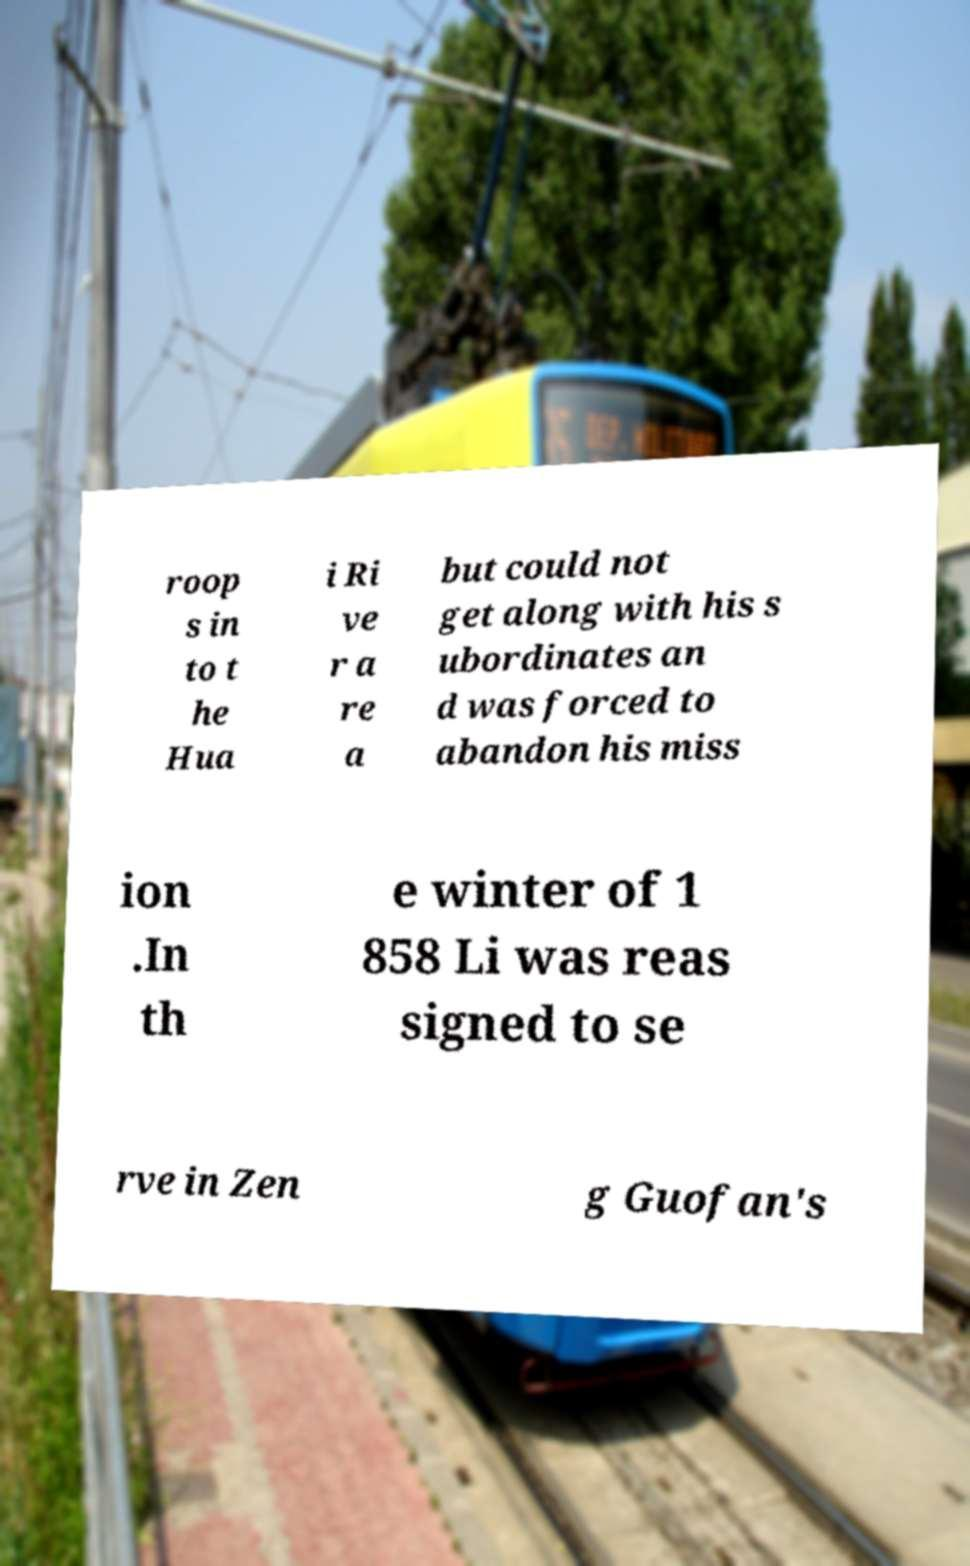Please read and relay the text visible in this image. What does it say? roop s in to t he Hua i Ri ve r a re a but could not get along with his s ubordinates an d was forced to abandon his miss ion .In th e winter of 1 858 Li was reas signed to se rve in Zen g Guofan's 